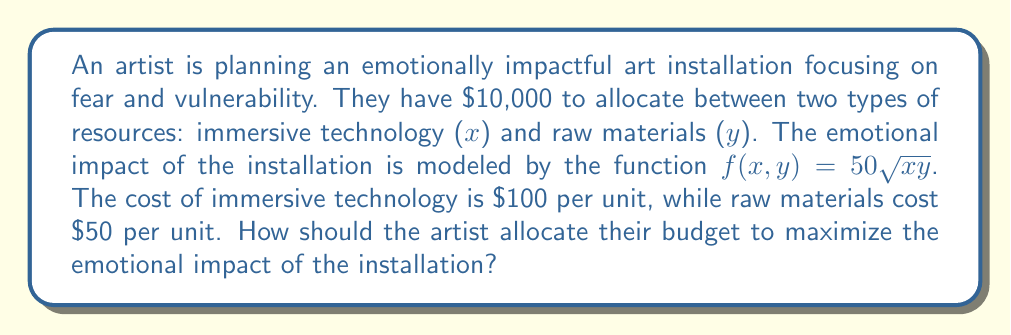Help me with this question. To solve this problem, we'll use the method of Lagrange multipliers:

1) Let's define our constraint function:
   $g(x,y) = 100x + 50y - 10000 = 0$

2) The Lagrangian function is:
   $L(x,y,\lambda) = f(x,y) - \lambda g(x,y)$
   $L(x,y,\lambda) = 50\sqrt{xy} - \lambda(100x + 50y - 10000)$

3) We now compute the partial derivatives and set them to zero:

   $\frac{\partial L}{\partial x} = \frac{25y}{\sqrt{xy}} - 100\lambda = 0$
   
   $\frac{\partial L}{\partial y} = \frac{25x}{\sqrt{xy}} - 50\lambda = 0$
   
   $\frac{\partial L}{\partial \lambda} = 100x + 50y - 10000 = 0$

4) From the first two equations:
   $\frac{25y}{\sqrt{xy}} = 100\lambda$ and $\frac{25x}{\sqrt{xy}} = 50\lambda$

5) Dividing these equations:
   $\frac{y}{x} = 2$
   $y = 2x$

6) Substituting this into the constraint equation:
   $100x + 50(2x) - 10000 = 0$
   $200x - 10000 = 0$
   $x = 50$

7) If $x = 50$, then $y = 100$

8) We can verify that this satisfies the budget constraint:
   $100(50) + 50(100) = 5000 + 5000 = 10000$

Therefore, the artist should spend $5000 on immersive technology (50 units) and $5000 on raw materials (100 units).
Answer: The artist should allocate $5000 for immersive technology (50 units) and $5000 for raw materials (100 units) to maximize the emotional impact of the installation. 